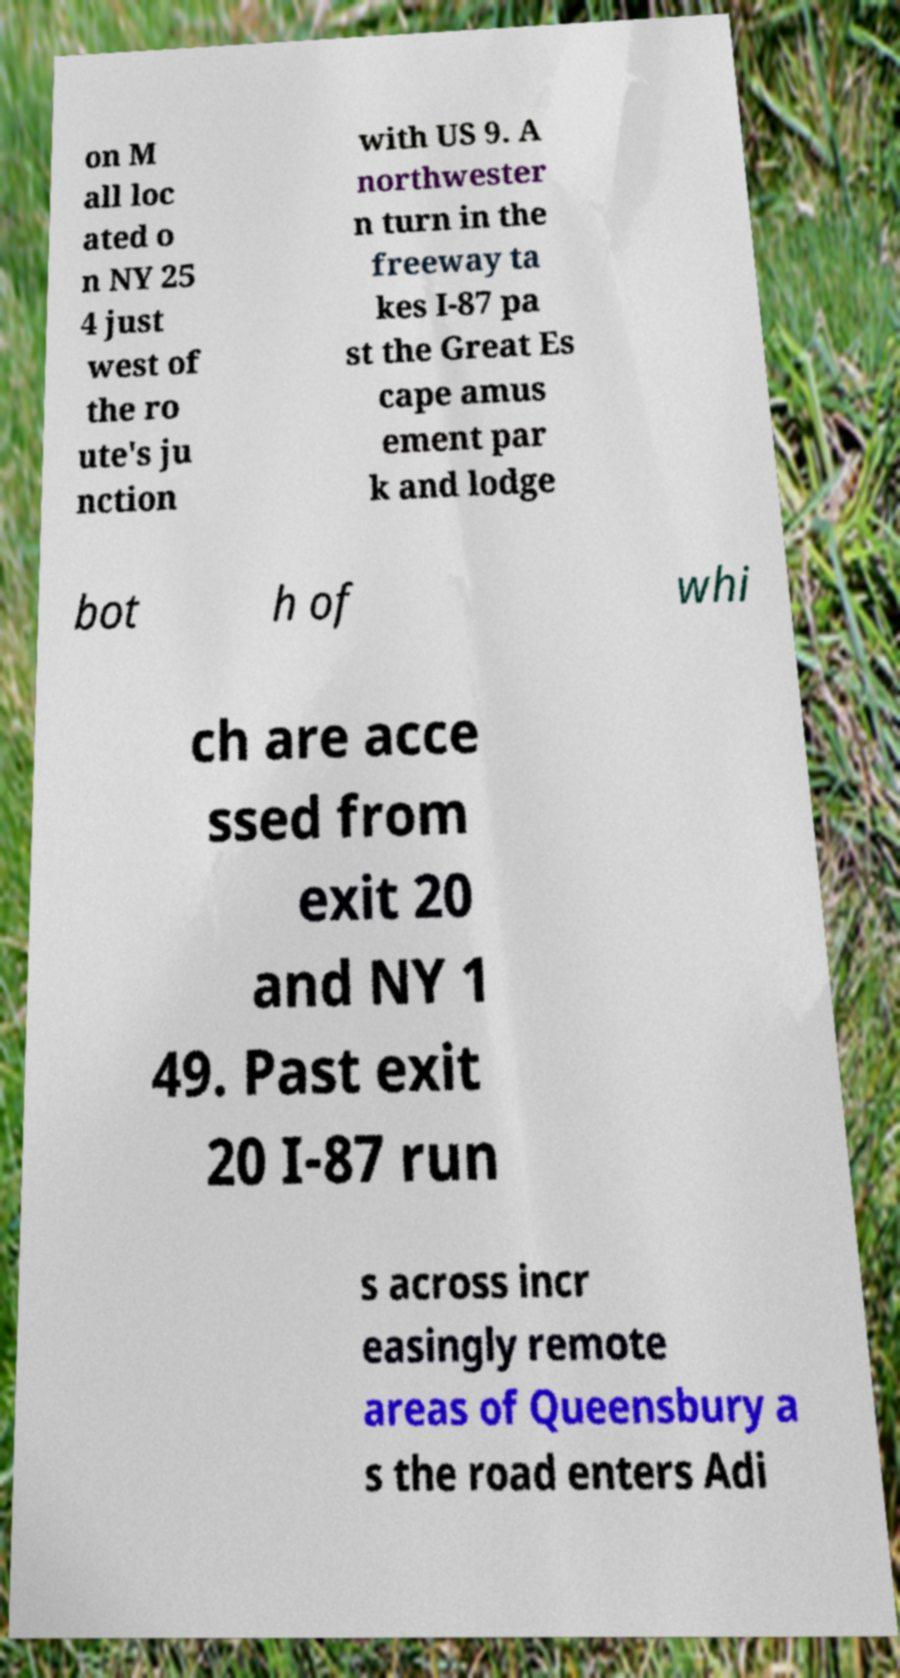What messages or text are displayed in this image? I need them in a readable, typed format. on M all loc ated o n NY 25 4 just west of the ro ute's ju nction with US 9. A northwester n turn in the freeway ta kes I-87 pa st the Great Es cape amus ement par k and lodge bot h of whi ch are acce ssed from exit 20 and NY 1 49. Past exit 20 I-87 run s across incr easingly remote areas of Queensbury a s the road enters Adi 